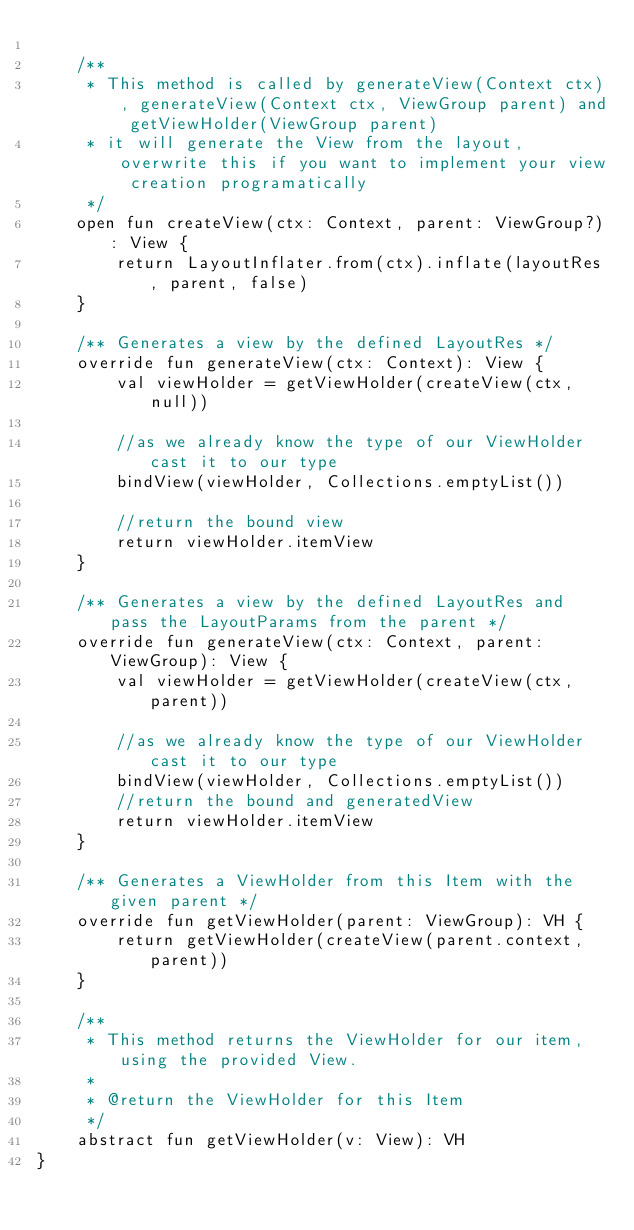Convert code to text. <code><loc_0><loc_0><loc_500><loc_500><_Kotlin_>
    /**
     * This method is called by generateView(Context ctx), generateView(Context ctx, ViewGroup parent) and getViewHolder(ViewGroup parent)
     * it will generate the View from the layout, overwrite this if you want to implement your view creation programatically
     */
    open fun createView(ctx: Context, parent: ViewGroup?): View {
        return LayoutInflater.from(ctx).inflate(layoutRes, parent, false)
    }

    /** Generates a view by the defined LayoutRes */
    override fun generateView(ctx: Context): View {
        val viewHolder = getViewHolder(createView(ctx, null))

        //as we already know the type of our ViewHolder cast it to our type
        bindView(viewHolder, Collections.emptyList())

        //return the bound view
        return viewHolder.itemView
    }

    /** Generates a view by the defined LayoutRes and pass the LayoutParams from the parent */
    override fun generateView(ctx: Context, parent: ViewGroup): View {
        val viewHolder = getViewHolder(createView(ctx, parent))

        //as we already know the type of our ViewHolder cast it to our type
        bindView(viewHolder, Collections.emptyList())
        //return the bound and generatedView
        return viewHolder.itemView
    }

    /** Generates a ViewHolder from this Item with the given parent */
    override fun getViewHolder(parent: ViewGroup): VH {
        return getViewHolder(createView(parent.context, parent))
    }

    /**
     * This method returns the ViewHolder for our item, using the provided View.
     *
     * @return the ViewHolder for this Item
     */
    abstract fun getViewHolder(v: View): VH
}</code> 